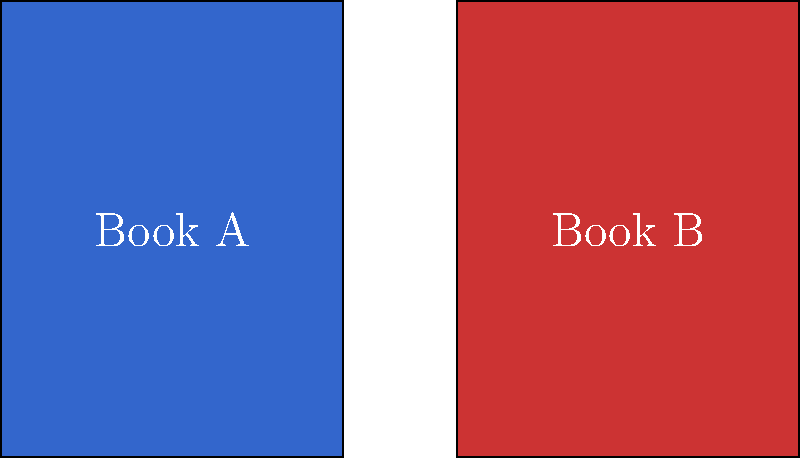Compare the use of color in the book covers shown above. How might the different color choices affect the reader's perception of each book's content and tone? To analyze the use of color in these book covers, we should consider the following steps:

1. Identify the colors:
   Book A: Deep blue
   Book B: Vibrant red

2. Consider color psychology:
   - Blue often represents calmness, depth, stability, and trust.
   - Red typically signifies passion, energy, danger, or excitement.

3. Evaluate potential genre implications:
   - The blue cover might suggest a mystery, drama, or non-fiction book.
   - The red cover could imply a thriller, romance, or action-packed story.

4. Assess emotional impact:
   - Blue may evoke a sense of introspection or melancholy.
   - Red might create feelings of urgency or intensity.

5. Consider contrast and visibility:
   - Both covers use white text, which stands out against the background colors.

6. Analyze potential symbolism:
   - Blue might symbolize depth of character or emotional complexity.
   - Red could represent conflict, love, or high stakes.

7. Reflect on reader expectations:
   - The blue cover may attract readers seeking a thoughtful or calm read.
   - The red cover might appeal to those looking for excitement or passion.
Answer: The blue cover suggests depth and calmness, potentially indicating a thoughtful or emotional story, while the red cover implies intensity and excitement, possibly signaling a more action-packed or passionate narrative. 